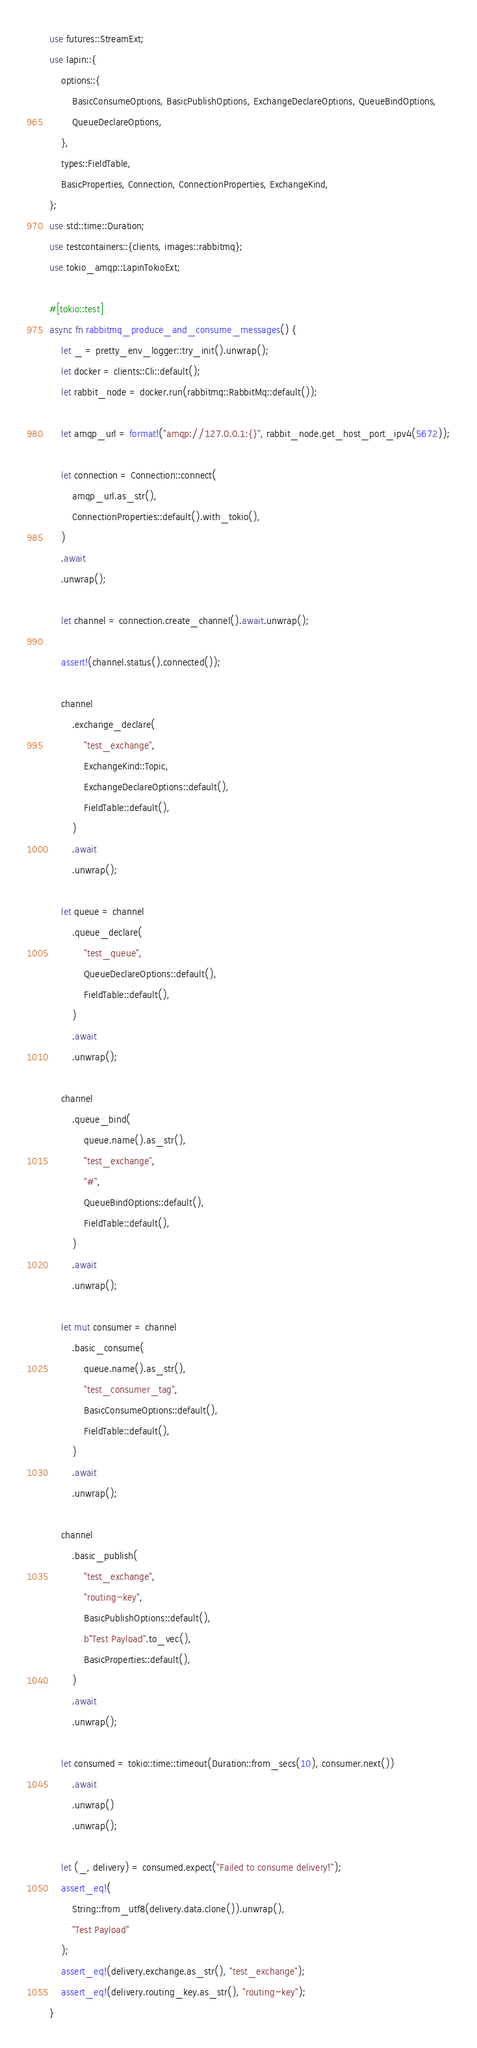Convert code to text. <code><loc_0><loc_0><loc_500><loc_500><_Rust_>use futures::StreamExt;
use lapin::{
    options::{
        BasicConsumeOptions, BasicPublishOptions, ExchangeDeclareOptions, QueueBindOptions,
        QueueDeclareOptions,
    },
    types::FieldTable,
    BasicProperties, Connection, ConnectionProperties, ExchangeKind,
};
use std::time::Duration;
use testcontainers::{clients, images::rabbitmq};
use tokio_amqp::LapinTokioExt;

#[tokio::test]
async fn rabbitmq_produce_and_consume_messages() {
    let _ = pretty_env_logger::try_init().unwrap();
    let docker = clients::Cli::default();
    let rabbit_node = docker.run(rabbitmq::RabbitMq::default());

    let amqp_url = format!("amqp://127.0.0.1:{}", rabbit_node.get_host_port_ipv4(5672));

    let connection = Connection::connect(
        amqp_url.as_str(),
        ConnectionProperties::default().with_tokio(),
    )
    .await
    .unwrap();

    let channel = connection.create_channel().await.unwrap();

    assert!(channel.status().connected());

    channel
        .exchange_declare(
            "test_exchange",
            ExchangeKind::Topic,
            ExchangeDeclareOptions::default(),
            FieldTable::default(),
        )
        .await
        .unwrap();

    let queue = channel
        .queue_declare(
            "test_queue",
            QueueDeclareOptions::default(),
            FieldTable::default(),
        )
        .await
        .unwrap();

    channel
        .queue_bind(
            queue.name().as_str(),
            "test_exchange",
            "#",
            QueueBindOptions::default(),
            FieldTable::default(),
        )
        .await
        .unwrap();

    let mut consumer = channel
        .basic_consume(
            queue.name().as_str(),
            "test_consumer_tag",
            BasicConsumeOptions::default(),
            FieldTable::default(),
        )
        .await
        .unwrap();

    channel
        .basic_publish(
            "test_exchange",
            "routing-key",
            BasicPublishOptions::default(),
            b"Test Payload".to_vec(),
            BasicProperties::default(),
        )
        .await
        .unwrap();

    let consumed = tokio::time::timeout(Duration::from_secs(10), consumer.next())
        .await
        .unwrap()
        .unwrap();

    let (_, delivery) = consumed.expect("Failed to consume delivery!");
    assert_eq!(
        String::from_utf8(delivery.data.clone()).unwrap(),
        "Test Payload"
    );
    assert_eq!(delivery.exchange.as_str(), "test_exchange");
    assert_eq!(delivery.routing_key.as_str(), "routing-key");
}
</code> 